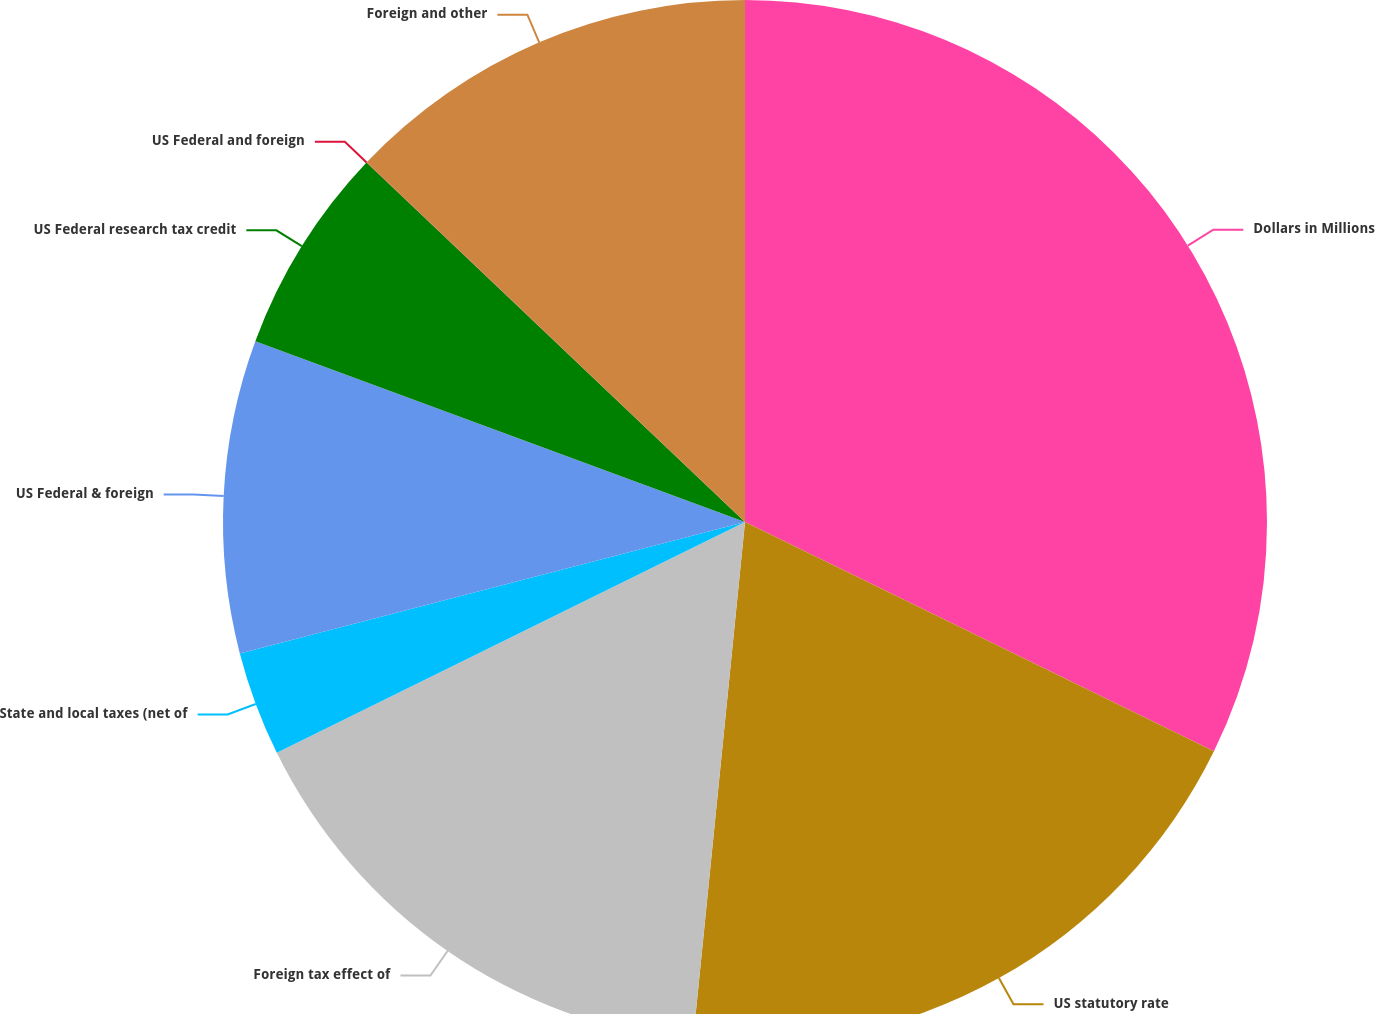Convert chart. <chart><loc_0><loc_0><loc_500><loc_500><pie_chart><fcel>Dollars in Millions<fcel>US statutory rate<fcel>Foreign tax effect of<fcel>State and local taxes (net of<fcel>US Federal & foreign<fcel>US Federal research tax credit<fcel>US Federal and foreign<fcel>Foreign and other<nl><fcel>32.24%<fcel>19.35%<fcel>16.12%<fcel>3.24%<fcel>9.68%<fcel>6.46%<fcel>0.01%<fcel>12.9%<nl></chart> 